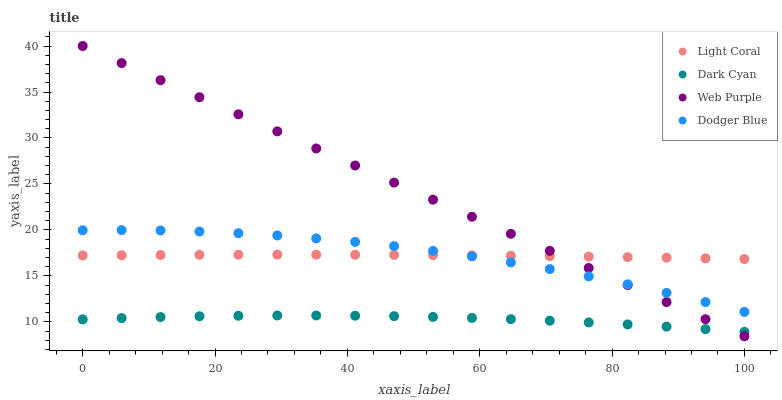Does Dark Cyan have the minimum area under the curve?
Answer yes or no. Yes. Does Web Purple have the maximum area under the curve?
Answer yes or no. Yes. Does Web Purple have the minimum area under the curve?
Answer yes or no. No. Does Dark Cyan have the maximum area under the curve?
Answer yes or no. No. Is Web Purple the smoothest?
Answer yes or no. Yes. Is Dodger Blue the roughest?
Answer yes or no. Yes. Is Dark Cyan the smoothest?
Answer yes or no. No. Is Dark Cyan the roughest?
Answer yes or no. No. Does Web Purple have the lowest value?
Answer yes or no. Yes. Does Dark Cyan have the lowest value?
Answer yes or no. No. Does Web Purple have the highest value?
Answer yes or no. Yes. Does Dark Cyan have the highest value?
Answer yes or no. No. Is Dark Cyan less than Dodger Blue?
Answer yes or no. Yes. Is Light Coral greater than Dark Cyan?
Answer yes or no. Yes. Does Web Purple intersect Dark Cyan?
Answer yes or no. Yes. Is Web Purple less than Dark Cyan?
Answer yes or no. No. Is Web Purple greater than Dark Cyan?
Answer yes or no. No. Does Dark Cyan intersect Dodger Blue?
Answer yes or no. No. 